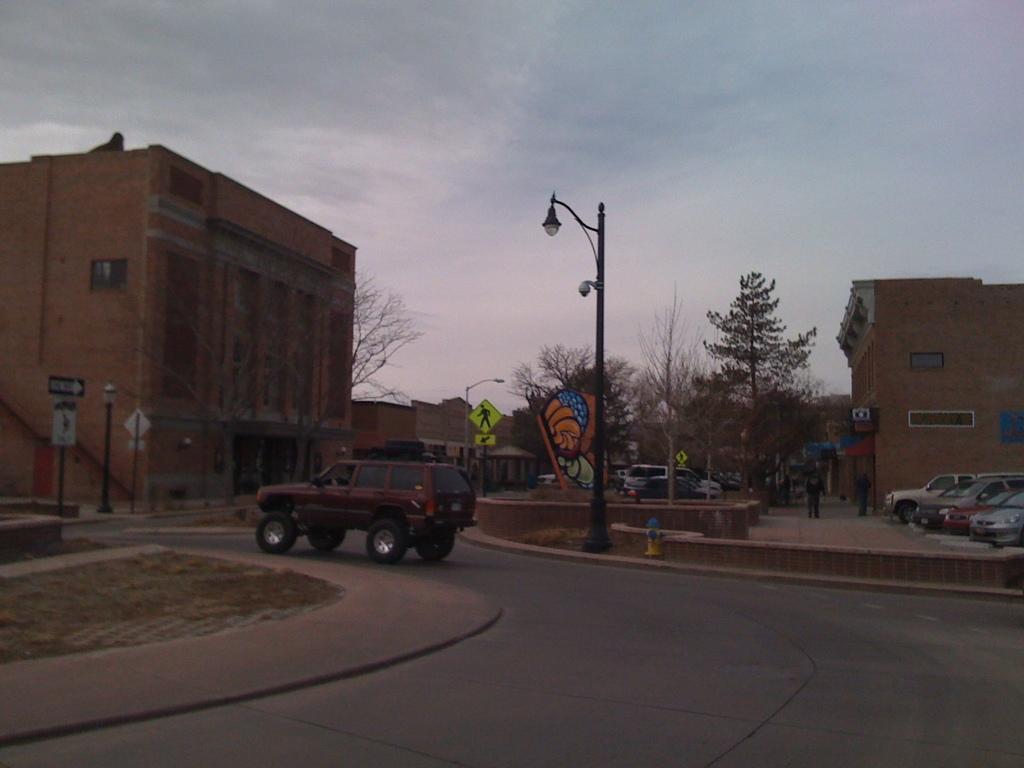How would you summarize this image in a sentence or two? An outdoor picture. A pole is in black color and it as a light. Sky is cloudy. Far there are buildings. This is a sign board. Far there are number of bare trees. Vehicle is travelling on a road. Vehicles are at parking area. The man is standing. 